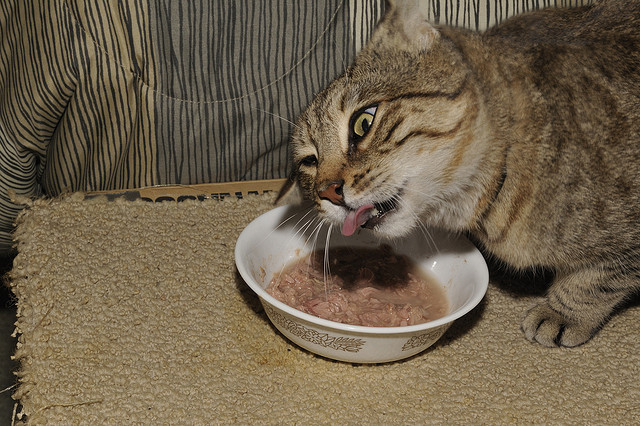Given an image of a piece of furniture in a house, identify the type of furniture. It is usually used to make the house look better and can be made of different kinds of material. Options: (a) This image contains a toilet (b) This image contains a couch (c) This image contains a dining table (d) This image contains a bed (e) This image contains a potted plant (f) This image contains a chair Upon review, the image primarily displays a cat engaging in eating from a bowl, which does not correspond to any of the furniture options provided. The background does show a slight glimpse of what might be part of a couch or chair, however, this is not the main focus of the image and does not allow for a definitive determination concerning the furniture type stated in the options. The scene instead offers a more casual glimpse into a domestic setting, potentially indicating a living area but not confirming any specific furniture type from the provided selections. 